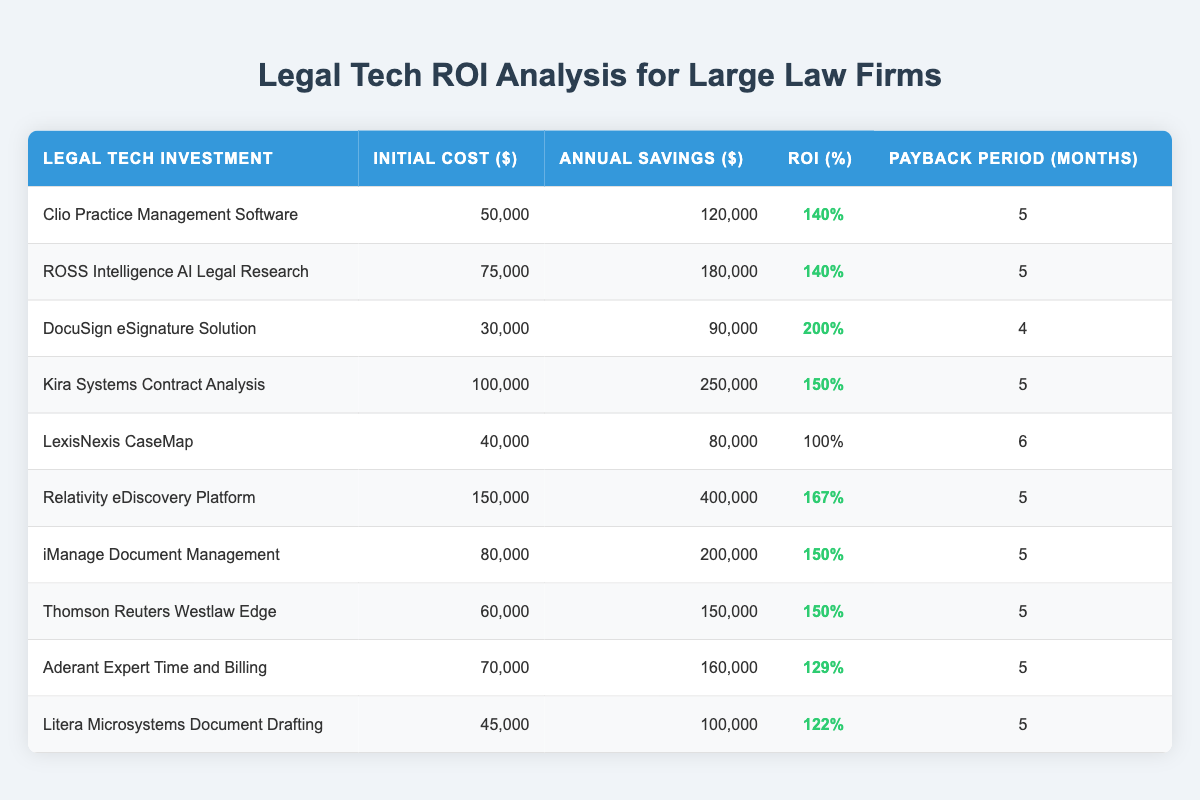What is the initial cost of the DocuSign eSignature Solution? The table shows the “Initial Cost ($)” for DocuSign eSignature Solution is listed as 30,000.
Answer: 30,000 Which legal tech investment has the highest ROI? By comparing the "ROI (%)" column, the DocuSign eSignature Solution has the highest ROI of 200%.
Answer: 200% Is the payback period for Relativity eDiscovery Platform less than 6 months? The table indicates the payback period for Relativity eDiscovery Platform is 5 months, which is less than 6 months.
Answer: Yes What is the average annual savings from all the legal tech investments listed? Summing the annual savings: 120,000 + 180,000 + 90,000 + 250,000 + 80,000 + 400,000 + 200,000 + 150,000 + 160,000 + 100,000 = 1,570,000. There are 10 investments, so the average is 1,570,000 / 10 = 157,000.
Answer: 157,000 How many legal tech investments have an ROI of at least 140%? The investments with at least 140% ROI are Clio Practice Management Software, ROSS Intelligence, DocuSign eSignature Solution, Kira Systems, Relativity eDiscovery Platform, iManage Document Management, and Thomson Reuters Westlaw Edge. This totals 7 investments.
Answer: 7 What is the difference between the initial cost of Kira Systems and the initial cost of LexisNexis CaseMap? The initial cost of Kira Systems is 100,000 and LexisNexis CaseMap is 40,000. The difference is 100,000 - 40,000 = 60,000.
Answer: 60,000 Does Aderant Expert Time and Billing offer annual savings greater than 150,000? The annual savings for Aderant Expert Time and Billing is 160,000, which is greater than 150,000.
Answer: Yes Which investments have a payback period of exactly 5 months? The investments with a payback period of exactly 5 months are Clio Practice Management Software, ROSS Intelligence AI Legal Research, Kira Systems, Relativity eDiscovery Platform, iManage Document Management, Thomson Reuters Westlaw Edge, Aderant Expert Time and Billing, and Litera Microsystems Document Drafting. Counting these shows there are 8 investments with a 5-month payback period.
Answer: 8 